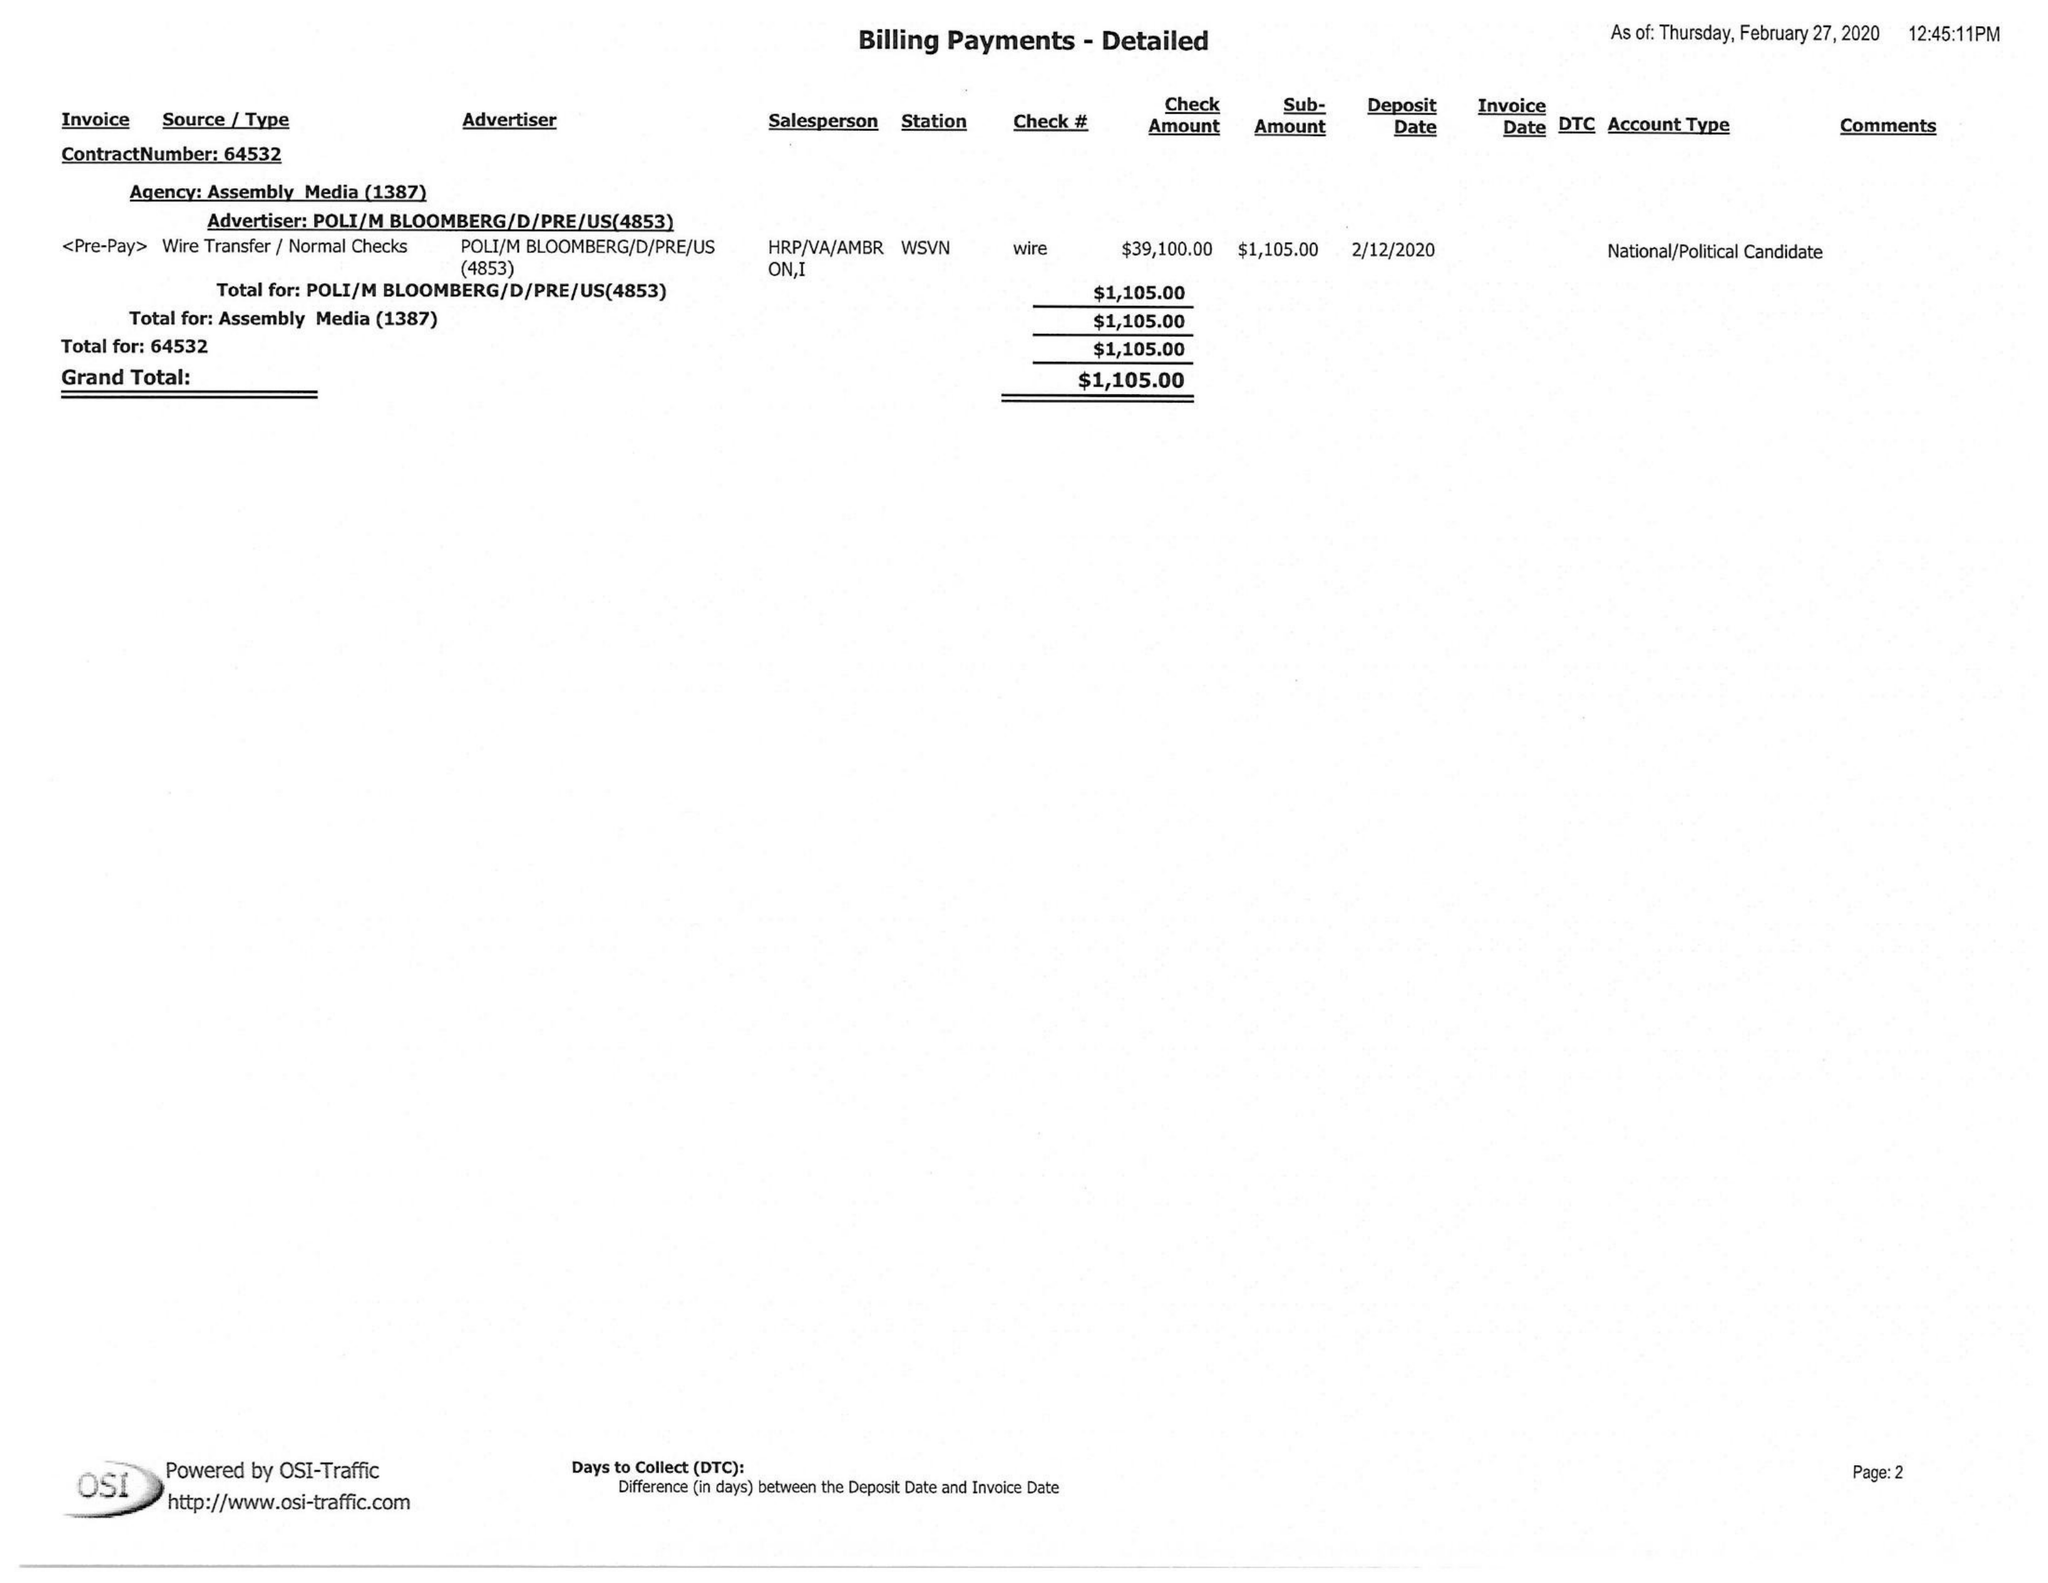What is the value for the contract_num?
Answer the question using a single word or phrase. 64532 